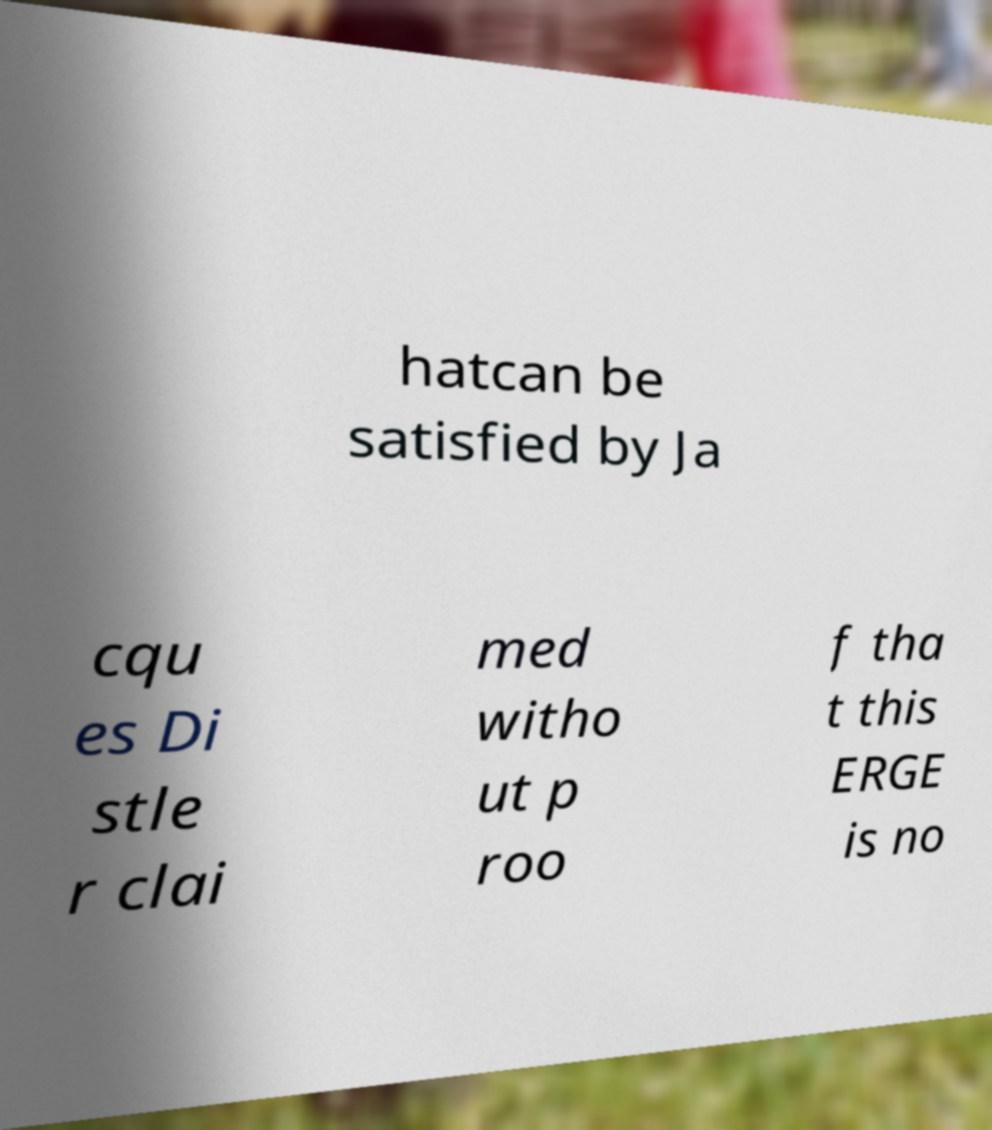Can you accurately transcribe the text from the provided image for me? hatcan be satisfied by Ja cqu es Di stle r clai med witho ut p roo f tha t this ERGE is no 